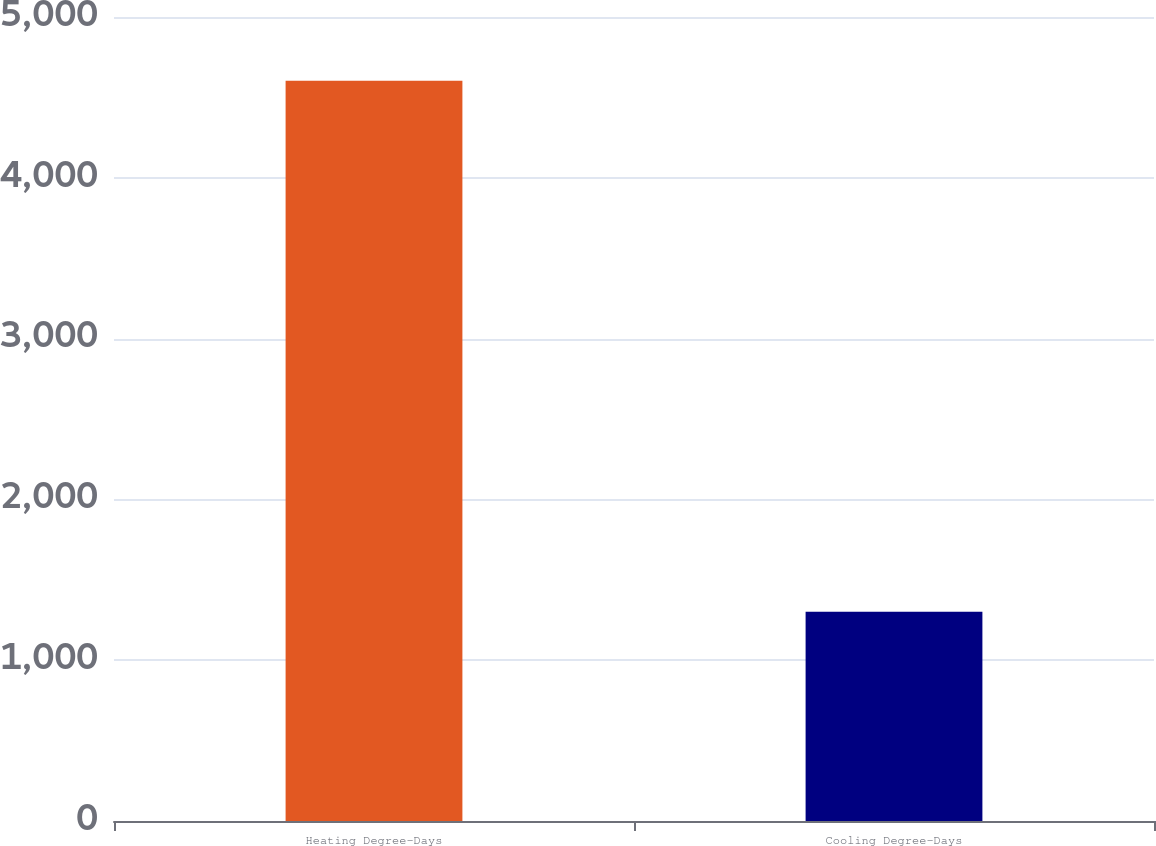Convert chart. <chart><loc_0><loc_0><loc_500><loc_500><bar_chart><fcel>Heating Degree-Days<fcel>Cooling Degree-Days<nl><fcel>4603<fcel>1301<nl></chart> 